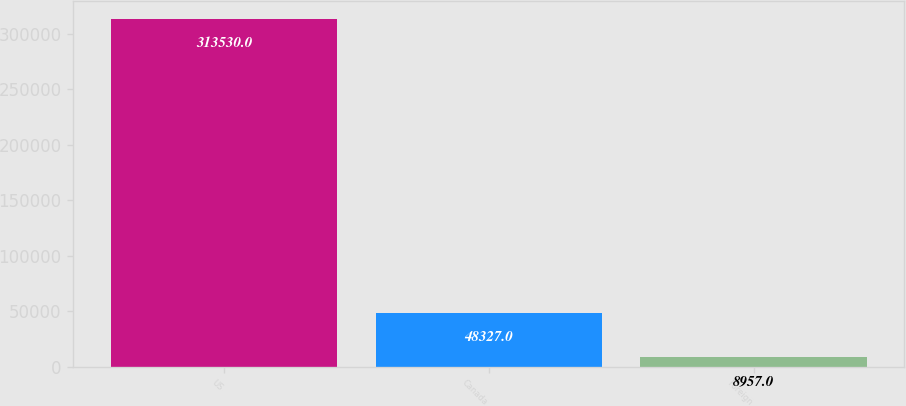Convert chart. <chart><loc_0><loc_0><loc_500><loc_500><bar_chart><fcel>US<fcel>Canada<fcel>Foreign<nl><fcel>313530<fcel>48327<fcel>8957<nl></chart> 